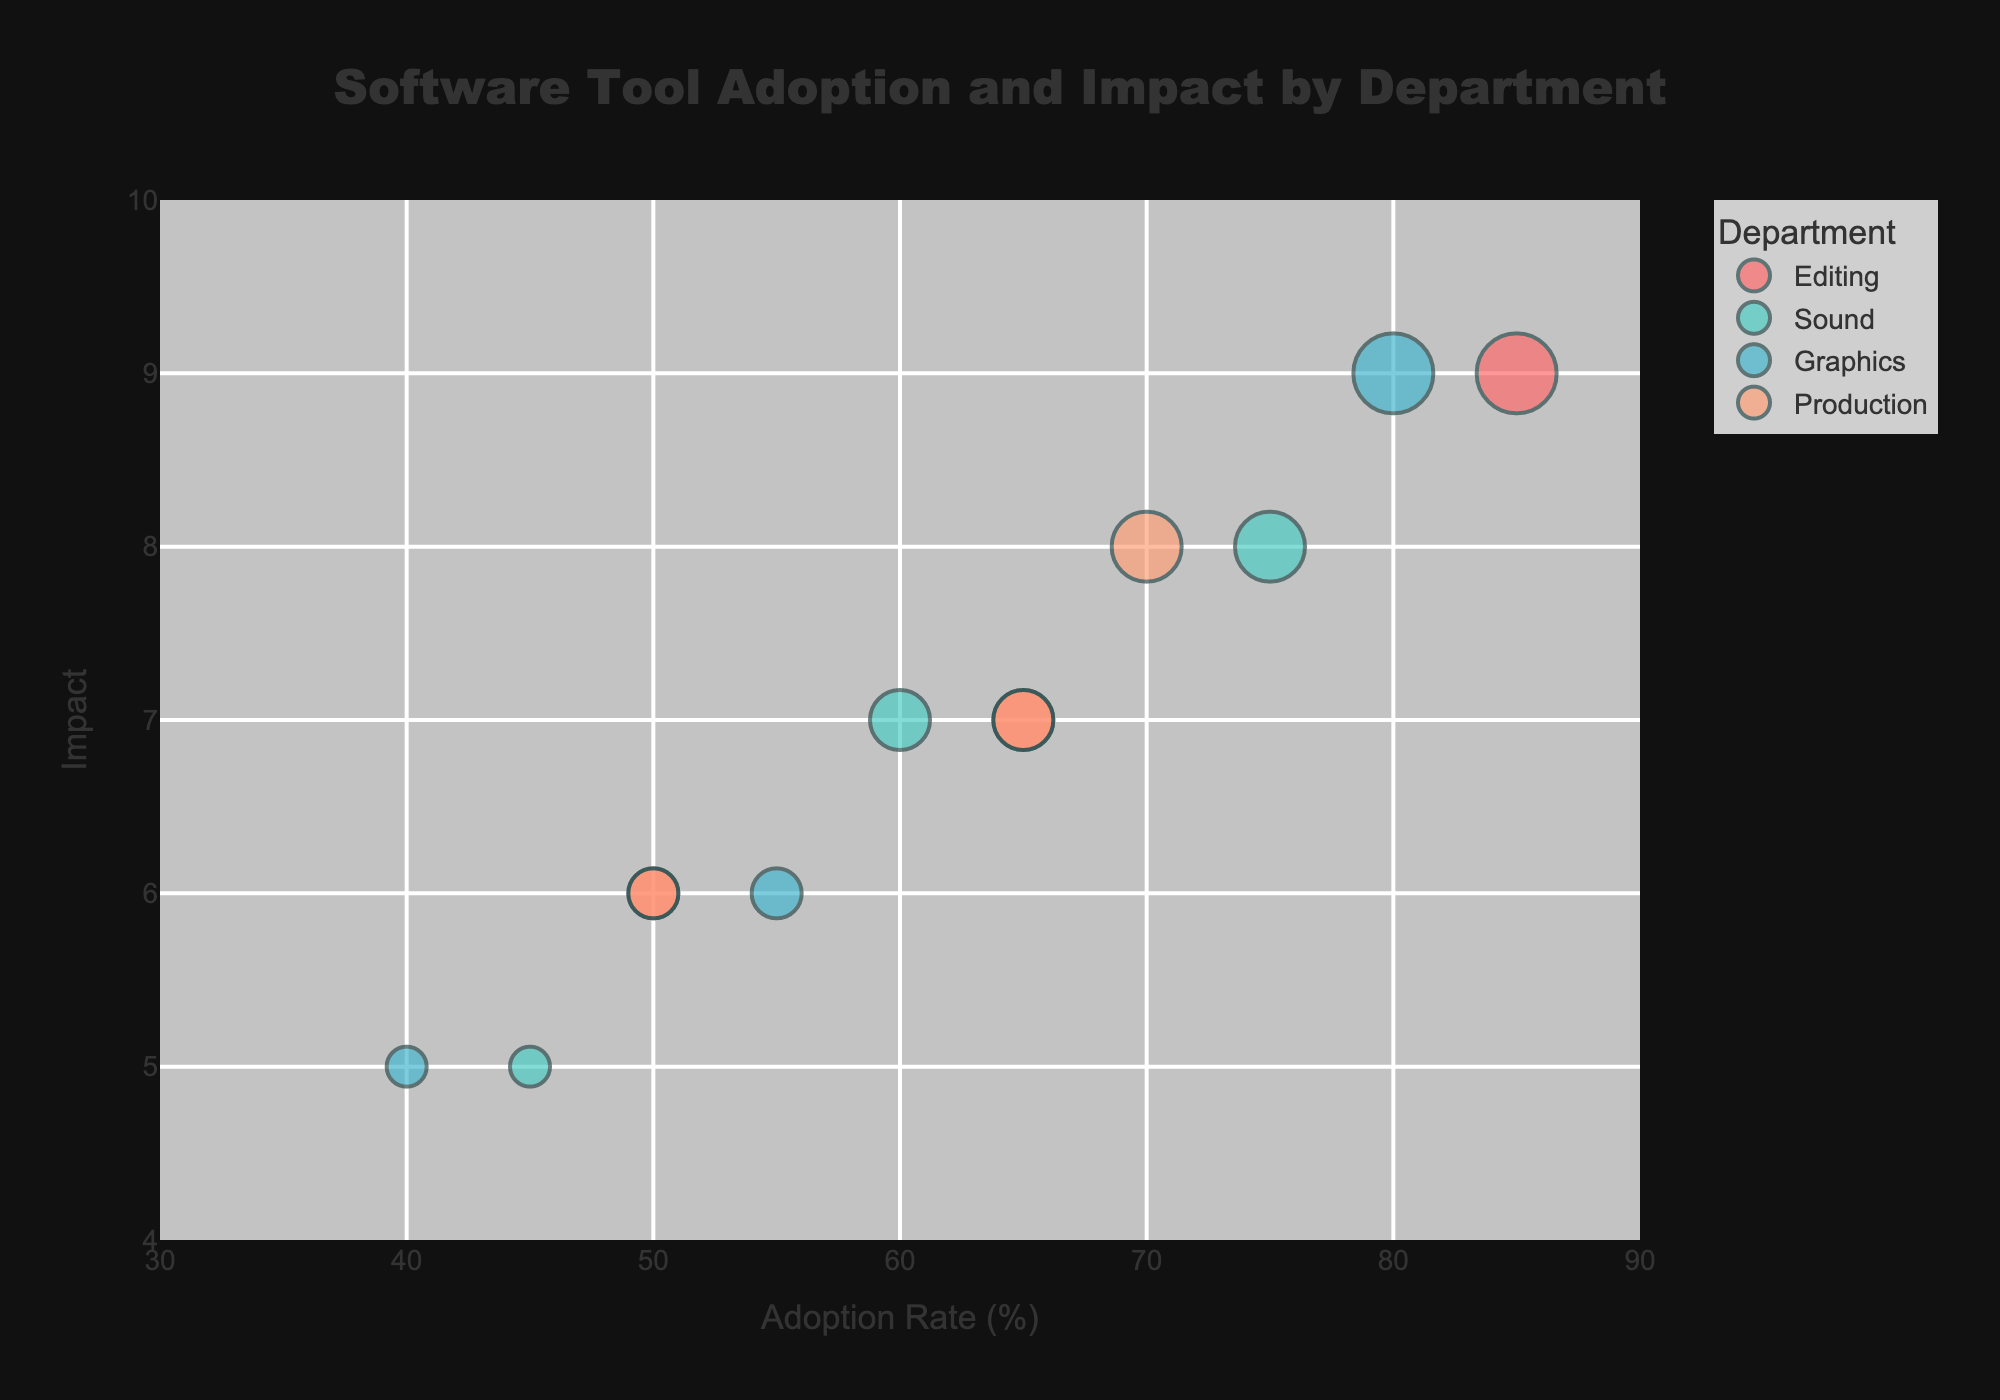What is the title of the figure? The title is located at the top of the figure, centered and highlighted in larger font size.
Answer: Software Tool Adoption and Impact by Department What is the Adoption Rate of Adobe Premiere Pro in the Editing department? Locate the bubble for Adobe Premiere Pro in the Editing department, and identify the Adoption Rate on the x-axis.
Answer: 85% Which department has the highest average Impact rating among its tools? Compute the average Impact score for the tools in each department, then compare these averages. Editing: (9 + 7 + 6) / 3 = 7.33, Sound: (8 + 7 + 5) / 3 = 6.67, Graphics: (9 + 6 + 5) / 3 = 6.67, Production: (8 + 7 + 6) / 3 = 7
Answer: Editing Which software tool has the highest Preference Weight in the Sound department? Find the bubble for each software tool in the Sound department and identify the one with the largest bubble size.
Answer: Audacity Among the Project Management tools in the Production department, which one has the lowest Adoption Rate? Look at the bubbles representing Asana, Trello, and JIRA in the Production department and compare their positions on the x-axis.
Answer: JIRA Compare the Preference Weights of Adobe Premiere Pro and Final Cut Pro. Which one is higher, and by how much? Identify the bubbles for Adobe Premiere Pro and Final Cut Pro in the Editing department, compare the bubble sizes, then calculate the difference. Adobe Premiere Pro (8 * 5 = 40) and Final Cut Pro (6 * 5 = 30), thus the difference is 40 - 30 = 10.
Answer: Adobe Premiere Pro has a higher Preference Weight by 10 units How does the Impact of Blender compare to Audacity? Locate the bubbles for Blender in the Graphics department and Audacity in the Sound department; compare their positions on the y-axis. Blender (6) is less than Audacity (8).
Answer: Blender has a lower Impact than Audacity What is the range of the y-axis (Impact) in the figure? Look at the y-axis and find the numerical values at the limits.
Answer: 4 to 10 How many software tools have an Adoption Rate between 60% and 70%? Identify the bubbles whose x-axis positions fall between 60 and 70, and count them. There are Final Cut Pro (65), Adobe Audition (60), and Asana (65) making a total of 3 tools.
Answer: 3 